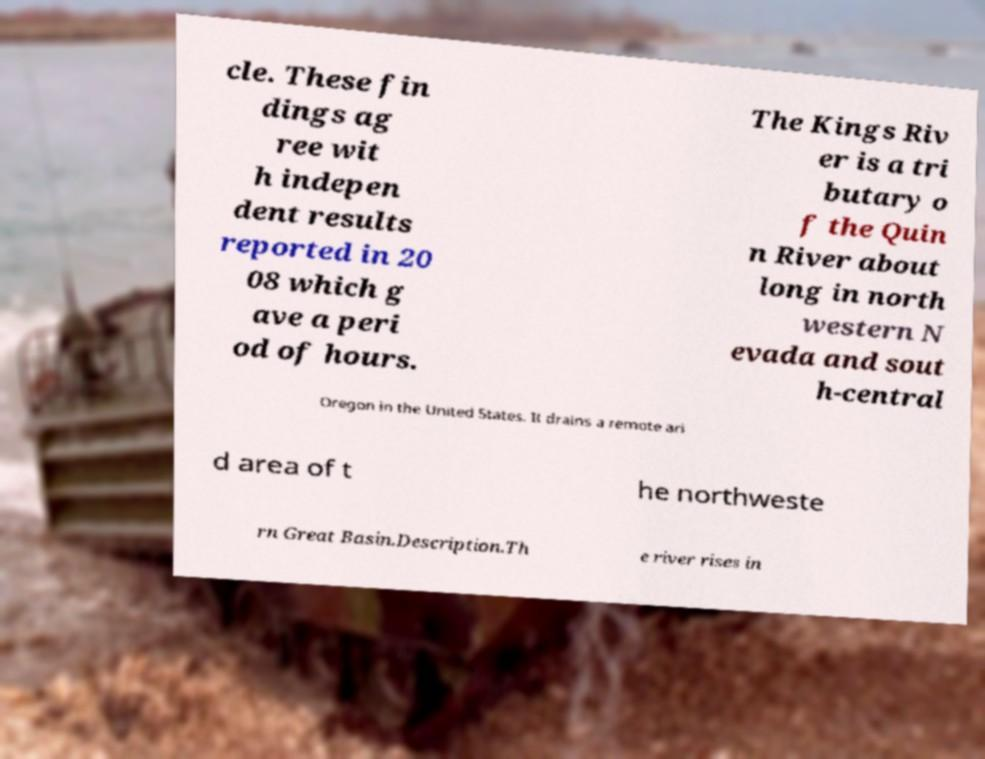Can you accurately transcribe the text from the provided image for me? cle. These fin dings ag ree wit h indepen dent results reported in 20 08 which g ave a peri od of hours. The Kings Riv er is a tri butary o f the Quin n River about long in north western N evada and sout h-central Oregon in the United States. It drains a remote ari d area of t he northweste rn Great Basin.Description.Th e river rises in 